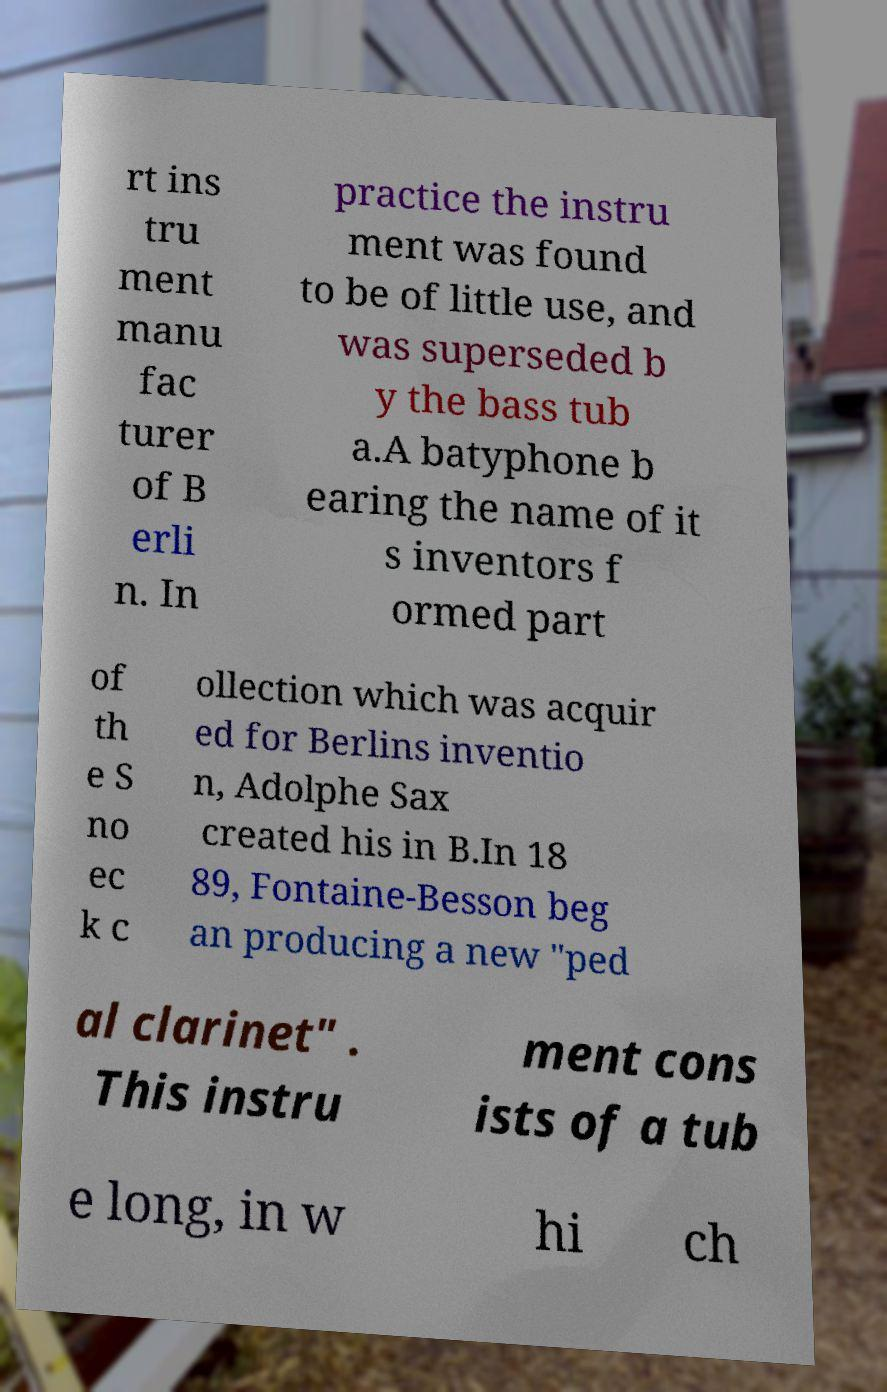Please identify and transcribe the text found in this image. rt ins tru ment manu fac turer of B erli n. In practice the instru ment was found to be of little use, and was superseded b y the bass tub a.A batyphone b earing the name of it s inventors f ormed part of th e S no ec k c ollection which was acquir ed for Berlins inventio n, Adolphe Sax created his in B.In 18 89, Fontaine-Besson beg an producing a new "ped al clarinet" . This instru ment cons ists of a tub e long, in w hi ch 